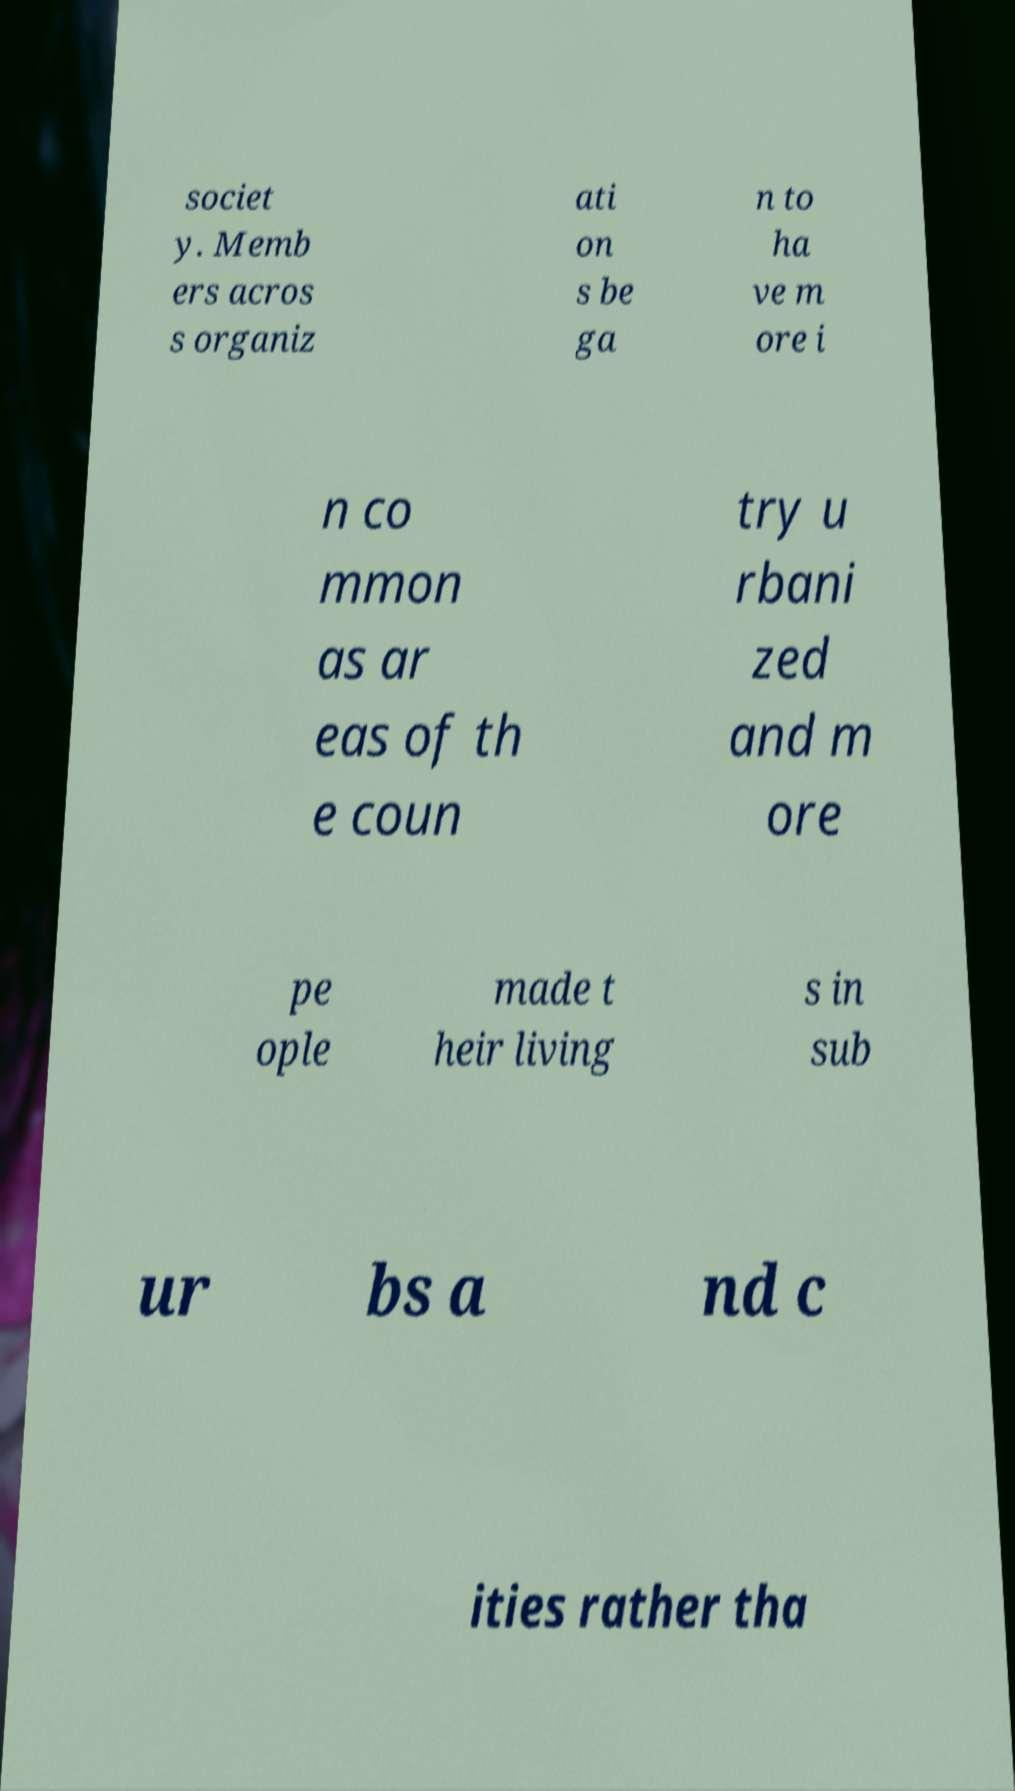Please read and relay the text visible in this image. What does it say? societ y. Memb ers acros s organiz ati on s be ga n to ha ve m ore i n co mmon as ar eas of th e coun try u rbani zed and m ore pe ople made t heir living s in sub ur bs a nd c ities rather tha 